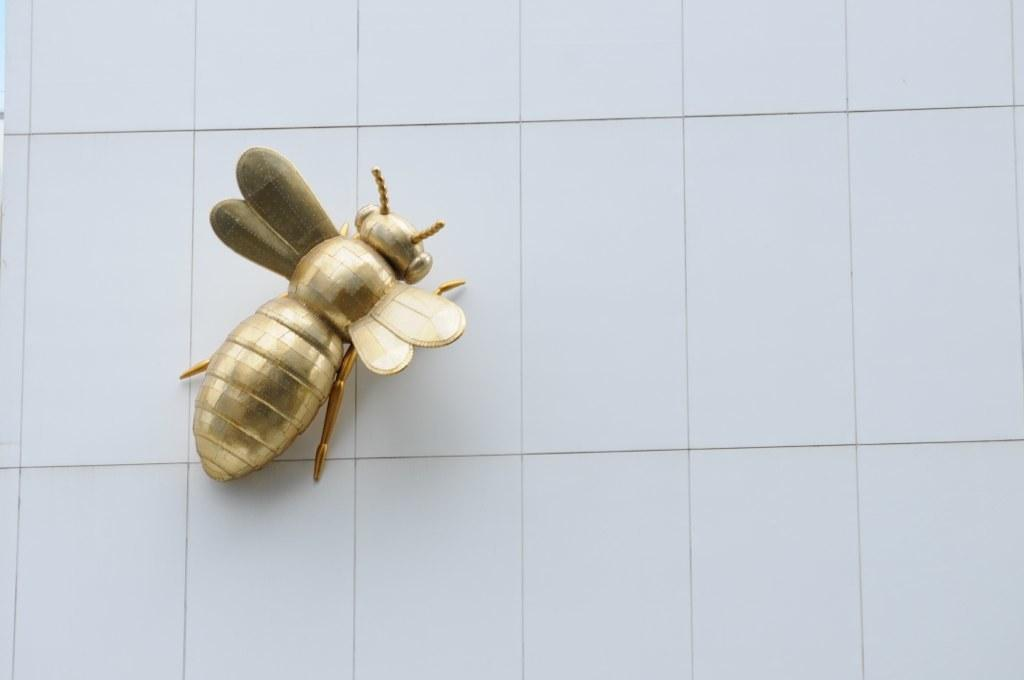What type of object is depicted in the image? There is a golden metal honey bee in the image. What color is the crayon used to draw the wheel in the image? There is no crayon or wheel present in the image; it features a golden metal honey bee. 